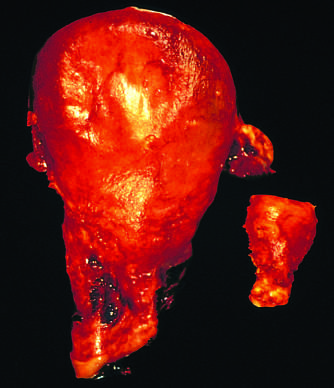was a gravid uterus removed for postpartum bleeding?
Answer the question using a single word or phrase. Yes 